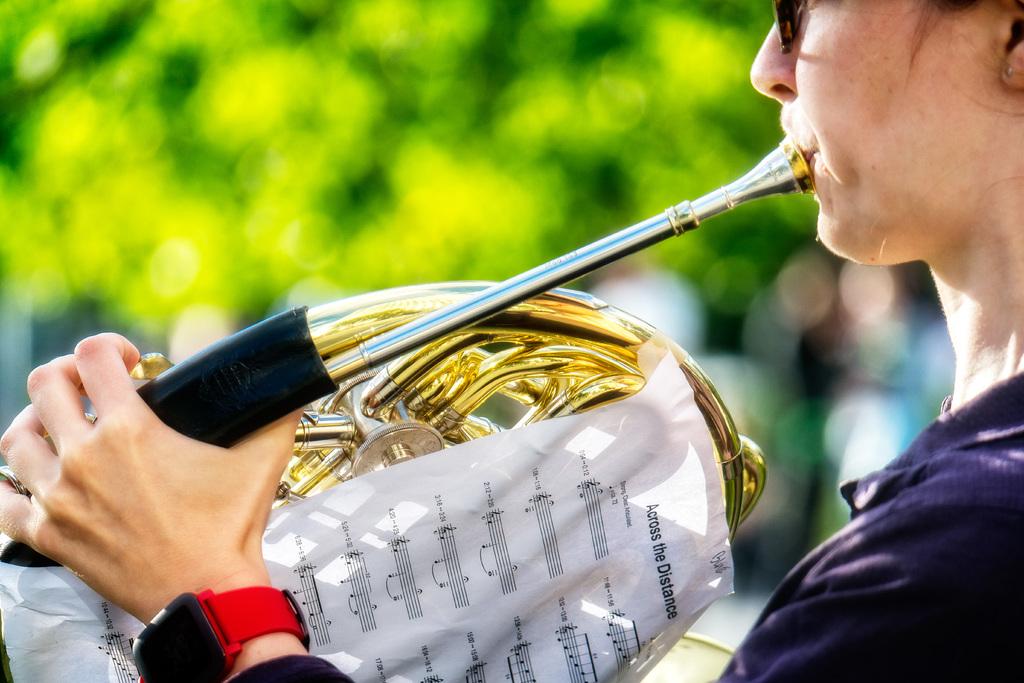What is the name of the song on the sheet of music?
Your answer should be compact. Across the distance. 